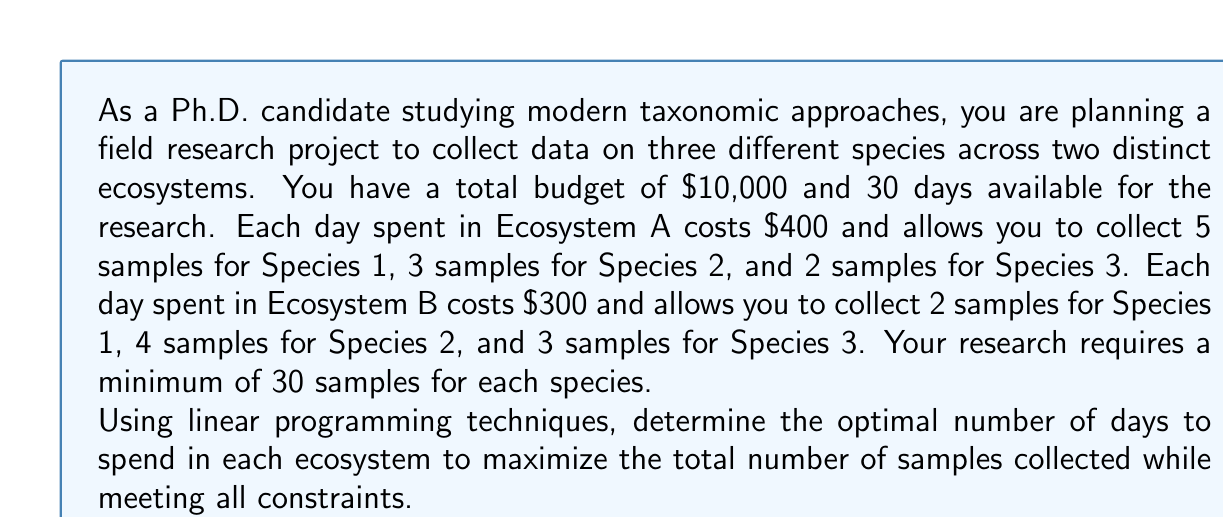Solve this math problem. To solve this problem using linear programming, we need to follow these steps:

1. Define the decision variables:
   Let $x$ be the number of days spent in Ecosystem A
   Let $y$ be the number of days spent in Ecosystem B

2. Set up the objective function:
   Maximize $Z = (5x + 2y) + (3x + 4y) + (2x + 3y) = 10x + 9y$

3. Identify the constraints:
   a) Budget constraint: $400x + 300y \leq 10000$
   b) Time constraint: $x + y \leq 30$
   c) Minimum samples for Species 1: $5x + 2y \geq 30$
   d) Minimum samples for Species 2: $3x + 4y \geq 30$
   e) Minimum samples for Species 3: $2x + 3y \geq 30$
   f) Non-negativity constraints: $x \geq 0, y \geq 0$

4. Solve the linear programming problem using the simplex method or a graphical approach.

5. Graphical approach:
   Plot the constraints on a coordinate system with x and y axes.
   
   [asy]
   import graph;
   size(200);
   
   xaxis("x (days in Ecosystem A)", 0, 30, Arrow);
   yaxis("y (days in Ecosystem B)", 0, 35, Arrow);
   
   draw((0,33.33)--(25,0), red+dashed); // Budget constraint
   draw((0,30)--(30,0), blue+dashed); // Time constraint
   draw((0,15)--(6,0), green+dashed); // Species 1 constraint
   draw((0,7.5)--(10,0), orange+dashed); // Species 2 constraint
   draw((0,10)--(15,0), purple+dashed); // Species 3 constraint
   
   label("Budget", (12.5,16.67), red);
   label("Time", (15,15), blue);
   label("Species 1", (3,7.5), green);
   label("Species 2", (5,3.75), orange);
   label("Species 3", (7.5,5), purple);
   
   dot((10,10), red);
   label("Optimal point", (10,10), SE);
   [/asy]

6. The feasible region is the area that satisfies all constraints. The optimal solution will be at one of the corner points of this region.

7. Evaluate the objective function at each corner point:
   Point (10, 10): $Z = 10(10) + 9(10) = 190$ samples
   Point (6, 15): $Z = 10(6) + 9(15) = 195$ samples
   Point (15, 7.5): $Z = 10(15) + 9(7.5) = 217.5$ samples

The optimal solution is to spend 15 days in Ecosystem A and 7.5 days in Ecosystem B, collecting a total of 217.5 samples.
Answer: The optimal allocation is to spend 15 days in Ecosystem A and 7.5 days in Ecosystem B, maximizing the total number of samples collected to 217.5. 